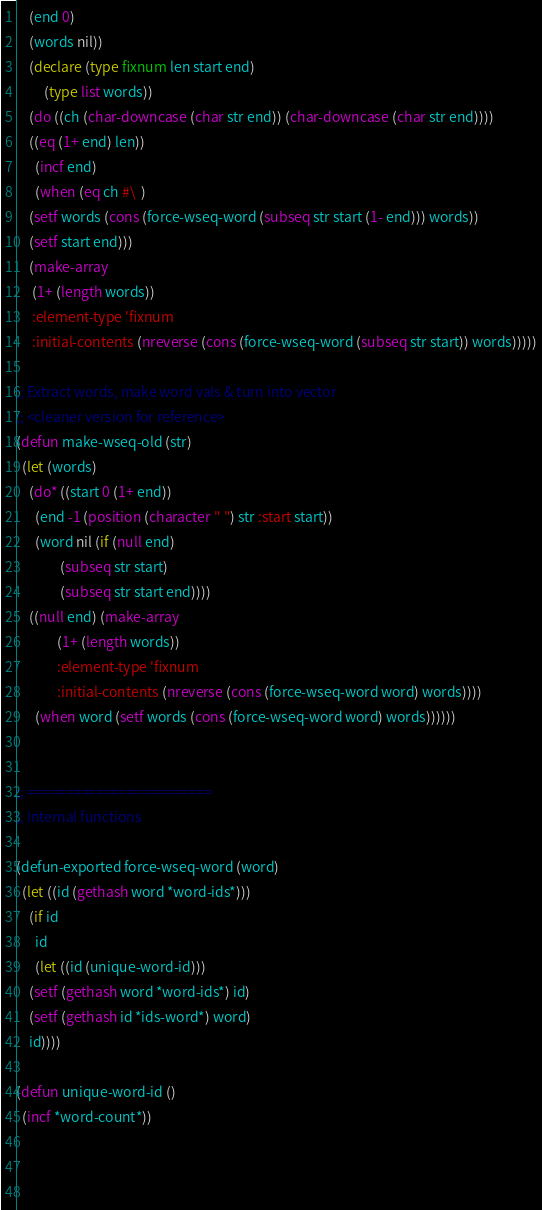<code> <loc_0><loc_0><loc_500><loc_500><_Lisp_>	(end 0)
	(words nil))
    (declare (type fixnum len start end)
	     (type list words))
    (do ((ch (char-downcase (char str end)) (char-downcase (char str end))))
	((eq (1+ end) len))
      (incf end)
      (when (eq ch #\  )
	(setf words (cons (force-wseq-word (subseq str start (1- end))) words))
	(setf start end)))
    (make-array
     (1+ (length words))
     :element-type 'fixnum
     :initial-contents (nreverse (cons (force-wseq-word (subseq str start)) words)))))

;; Extract words, make word vals & turn into vector
;; <cleaner version for reference>
(defun make-wseq-old (str)
  (let (words)
    (do* ((start 0 (1+ end))
	  (end -1 (position (character " ") str :start start))
	  (word nil (if (null end) 
		      (subseq str start)
		      (subseq str start end))))
	((null end) (make-array
		     (1+ (length words))
		     :element-type 'fixnum
		     :initial-contents (nreverse (cons (force-wseq-word word) words))))
      (when word (setf words (cons (force-wseq-word word) words))))))


;; ========================
;; Internal functions

(defun-exported force-wseq-word (word)
  (let ((id (gethash word *word-ids*)))
    (if id
      id
      (let ((id (unique-word-id)))
	(setf (gethash word *word-ids*) id)
	(setf (gethash id *ids-word*) word)
	id))))

(defun unique-word-id ()
  (incf *word-count*))

    
	

</code> 